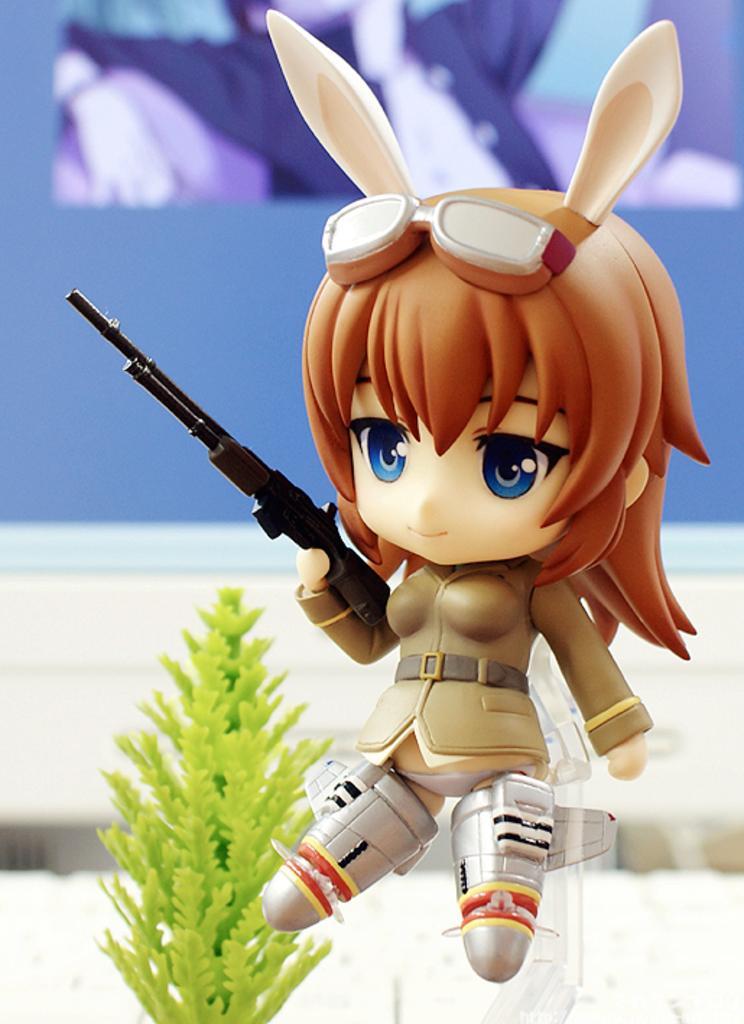Describe this image in one or two sentences. In this image I can see a toy is in the shape of a girl holding the gun. On the left side it is a plastic plant. 